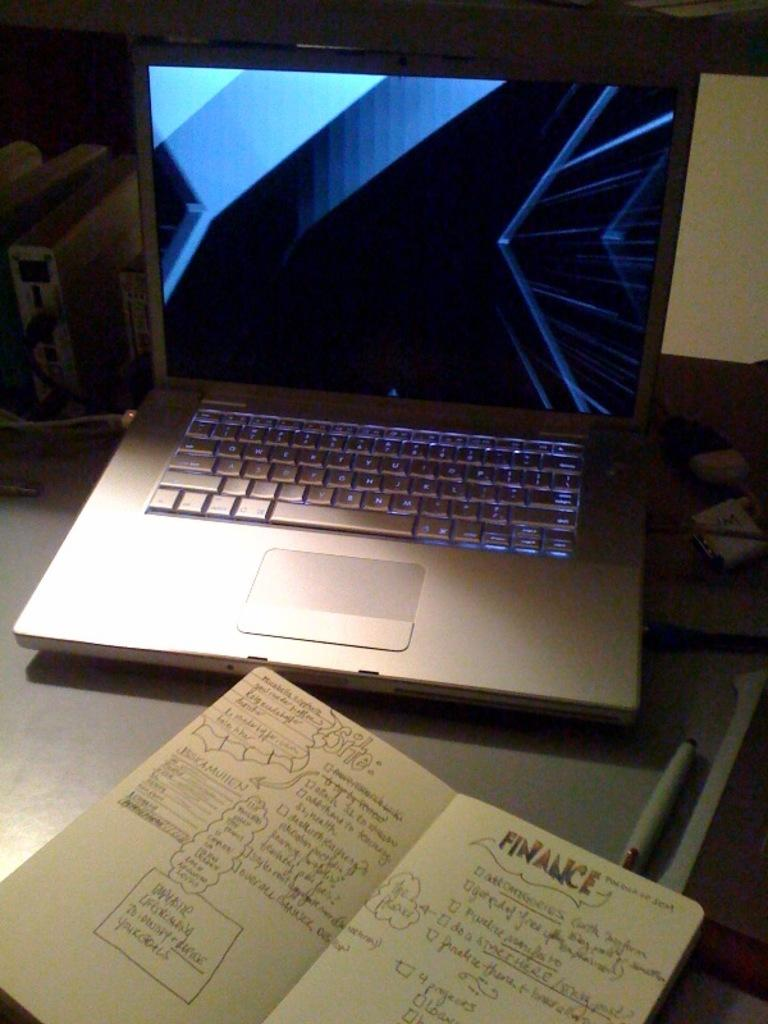Provide a one-sentence caption for the provided image. An open laptop with an open notebook that reads finance on top of the right page. 